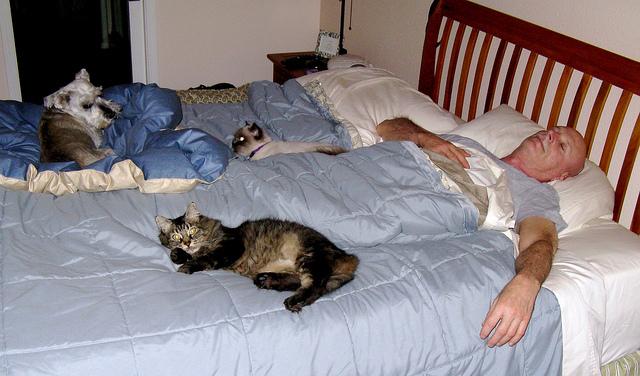How many different species of animal are relaxing in bed?
Short answer required. 2. Does the man mind having the pets on his bed?
Concise answer only. No. Are the animal asleep?
Be succinct. No. 